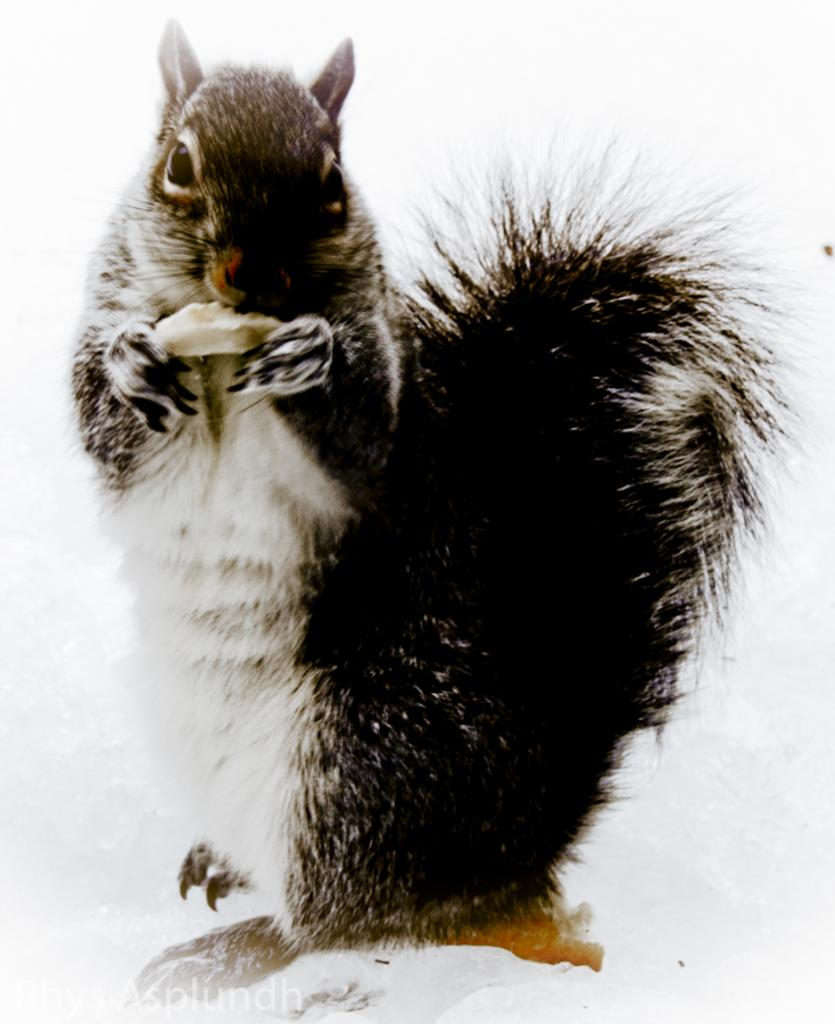What animal is present in the image? There is a rabbit in the image. What is the rabbit doing in the image? The rabbit is holding an object. What type of terrain is the rabbit standing on? The rabbit is standing on snow. Is there any text or logo visible in the image? Yes, there is a watermark in the bottom left corner of the image. What type of insect can be seen crawling on the bedroom wall in the image? There is no bedroom or insect present in the image; it features a rabbit standing on snow. 